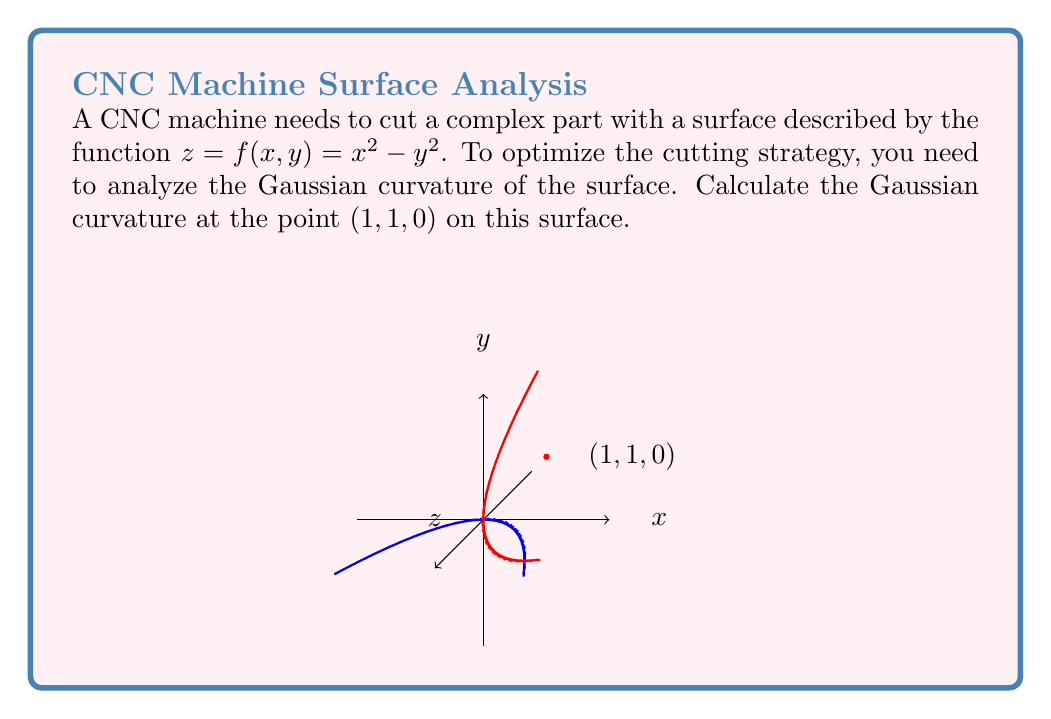Teach me how to tackle this problem. To calculate the Gaussian curvature, we'll follow these steps:

1) The Gaussian curvature K is given by:

   $$K = \frac{LN - M^2}{EG - F^2}$$

   where L, M, N are coefficients of the second fundamental form, and E, G, F are coefficients of the first fundamental form.

2) First, we need to calculate the partial derivatives:

   $$f_x = 2x, \quad f_y = -2y, \quad f_{xx} = 2, \quad f_{yy} = -2, \quad f_{xy} = 0$$

3) Now we can calculate E, F, G:

   $$E = 1 + f_x^2 = 1 + 4x^2$$
   $$F = f_x f_y = -4xy$$
   $$G = 1 + f_y^2 = 1 + 4y^2$$

4) Next, we calculate the normal vector:

   $$\vec{N} = \frac{(-f_x, -f_y, 1)}{\sqrt{1 + f_x^2 + f_y^2}} = \frac{(-2x, 2y, 1)}{\sqrt{1 + 4x^2 + 4y^2}}$$

5) Now we can calculate L, M, N:

   $$L = \frac{f_{xx}}{\sqrt{1 + f_x^2 + f_y^2}} = \frac{2}{\sqrt{1 + 4x^2 + 4y^2}}$$
   
   $$M = \frac{f_{xy}}{\sqrt{1 + f_x^2 + f_y^2}} = 0$$
   
   $$N = \frac{f_{yy}}{\sqrt{1 + f_x^2 + f_y^2}} = \frac{-2}{\sqrt{1 + 4x^2 + 4y^2}}$$

6) Now we can substitute these values into the formula for K:

   $$K = \frac{LN - M^2}{EG - F^2} = \frac{(\frac{2}{\sqrt{1 + 4x^2 + 4y^2}})(\frac{-2}{\sqrt{1 + 4x^2 + 4y^2}}) - 0^2}{(1 + 4x^2)(1 + 4y^2) - (-4xy)^2}$$

7) Simplify:

   $$K = \frac{-4}{(1 + 4x^2 + 4y^2)((1 + 4x^2)(1 + 4y^2) - 16x^2y^2)}$$

8) At the point (1, 1, 0), substitute x = 1 and y = 1:

   $$K = \frac{-4}{(1 + 4 + 4)((1 + 4)(1 + 4) - 16)} = \frac{-4}{9(25 - 16)} = \frac{-4}{81}$$

Therefore, the Gaussian curvature at the point (1, 1, 0) is $-\frac{4}{81}$.
Answer: $-\frac{4}{81}$ 